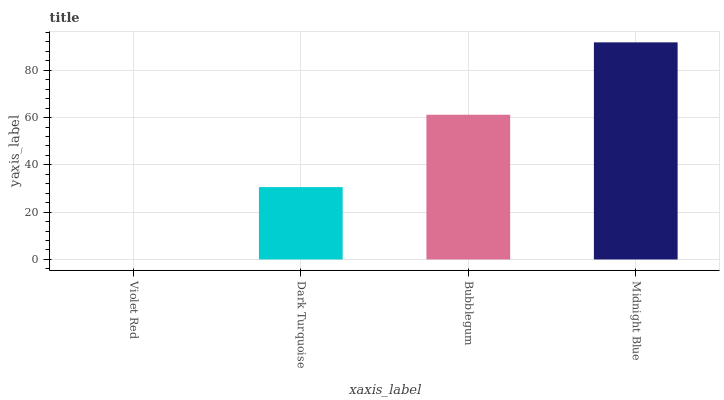Is Dark Turquoise the minimum?
Answer yes or no. No. Is Dark Turquoise the maximum?
Answer yes or no. No. Is Dark Turquoise greater than Violet Red?
Answer yes or no. Yes. Is Violet Red less than Dark Turquoise?
Answer yes or no. Yes. Is Violet Red greater than Dark Turquoise?
Answer yes or no. No. Is Dark Turquoise less than Violet Red?
Answer yes or no. No. Is Bubblegum the high median?
Answer yes or no. Yes. Is Dark Turquoise the low median?
Answer yes or no. Yes. Is Dark Turquoise the high median?
Answer yes or no. No. Is Bubblegum the low median?
Answer yes or no. No. 